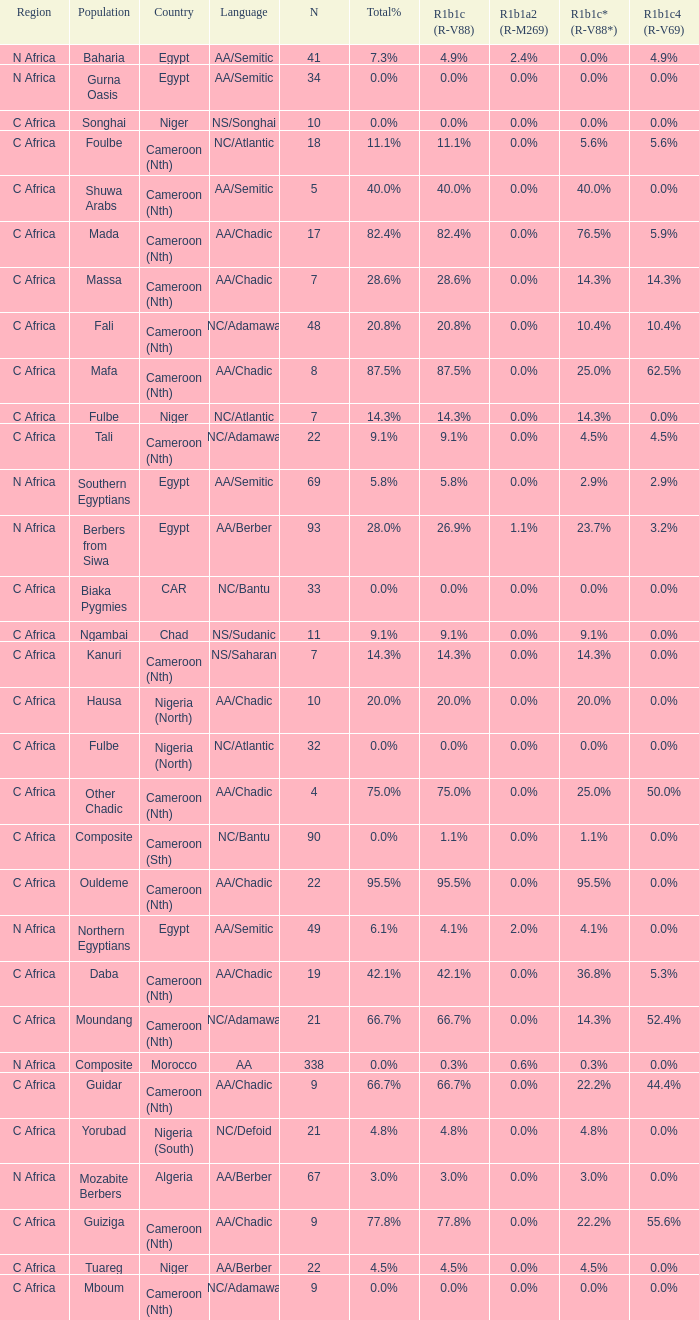What languages are spoken in Niger with r1b1c (r-v88) of 0.0%? NS/Songhai. 